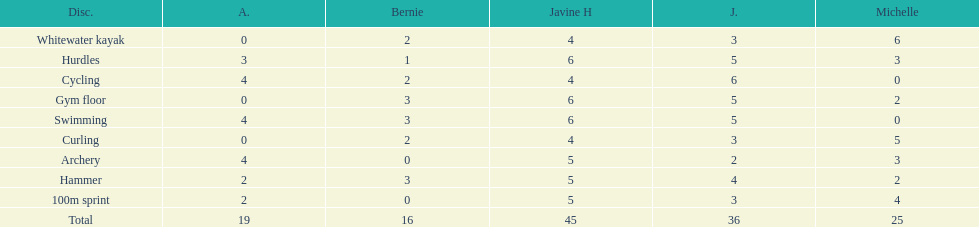Which of the girls had the least amount in archery? Bernie. 